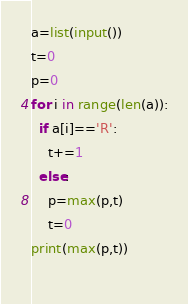<code> <loc_0><loc_0><loc_500><loc_500><_Python_>a=list(input())
t=0
p=0
for i in range(len(a)):
  if a[i]=='R':
    t+=1
  else:
    p=max(p,t)
    t=0
print(max(p,t))
    </code> 